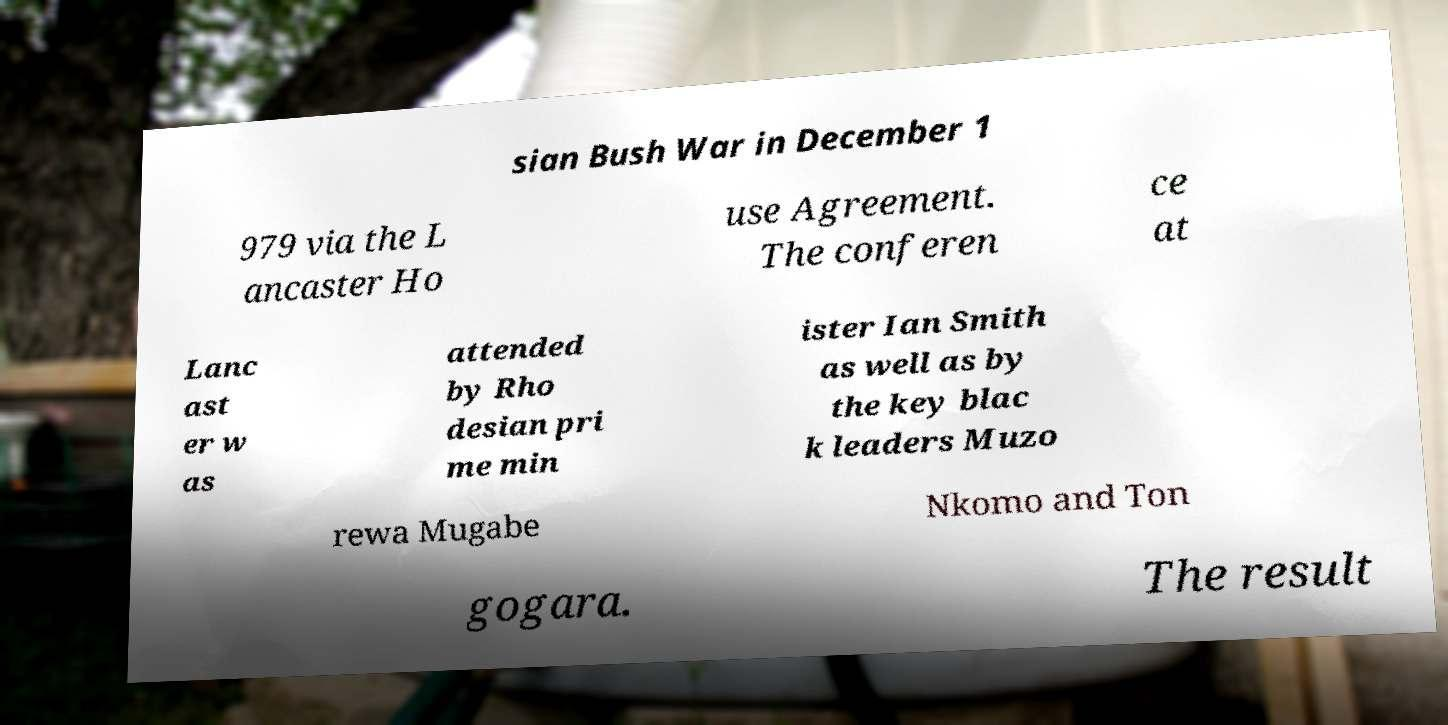Please read and relay the text visible in this image. What does it say? sian Bush War in December 1 979 via the L ancaster Ho use Agreement. The conferen ce at Lanc ast er w as attended by Rho desian pri me min ister Ian Smith as well as by the key blac k leaders Muzo rewa Mugabe Nkomo and Ton gogara. The result 